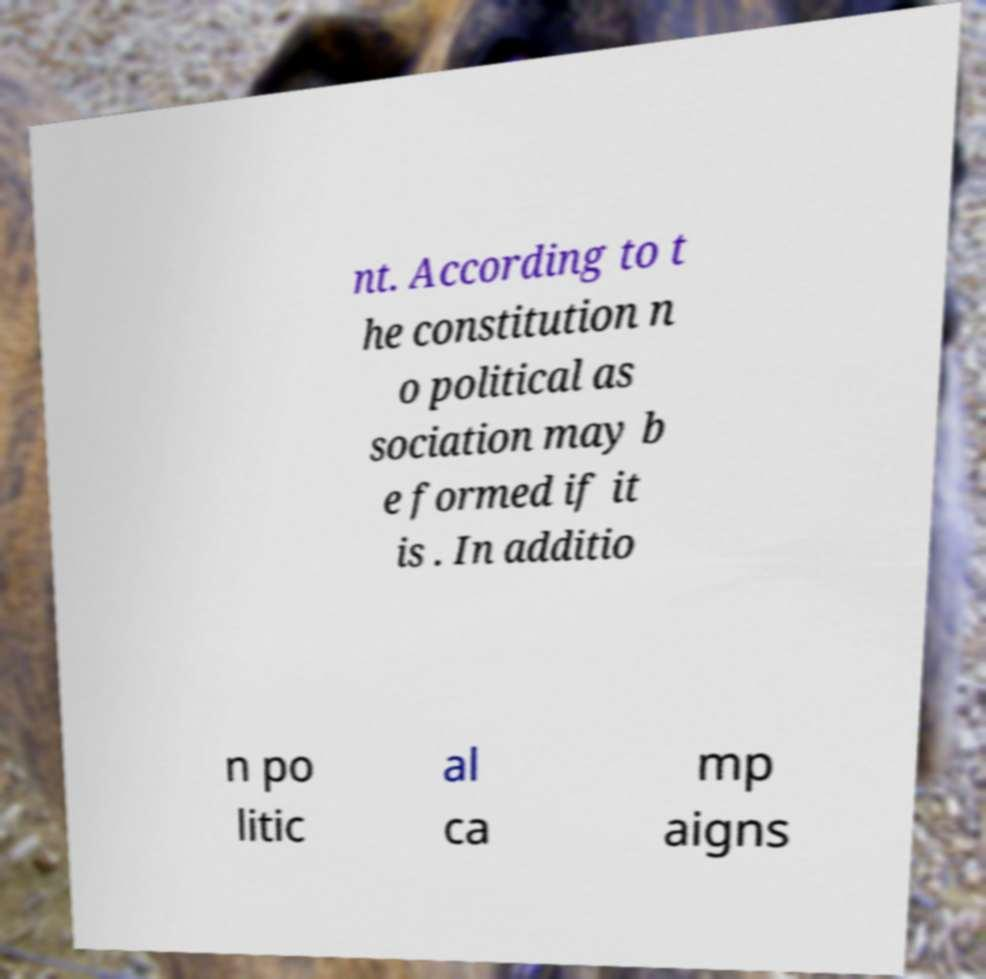Please read and relay the text visible in this image. What does it say? nt. According to t he constitution n o political as sociation may b e formed if it is . In additio n po litic al ca mp aigns 